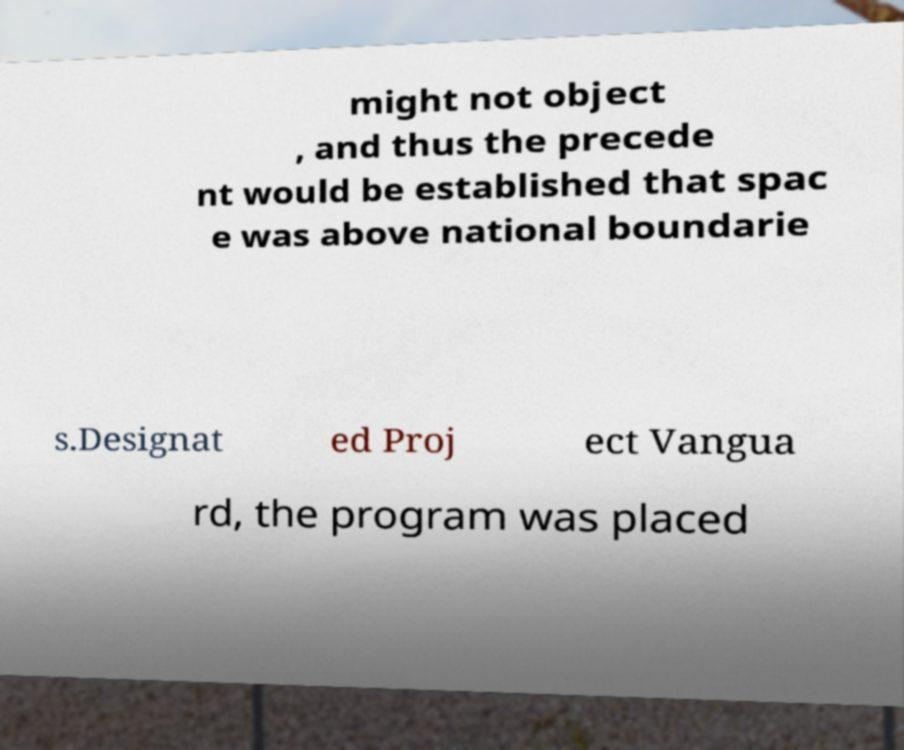Can you read and provide the text displayed in the image?This photo seems to have some interesting text. Can you extract and type it out for me? might not object , and thus the precede nt would be established that spac e was above national boundarie s.Designat ed Proj ect Vangua rd, the program was placed 